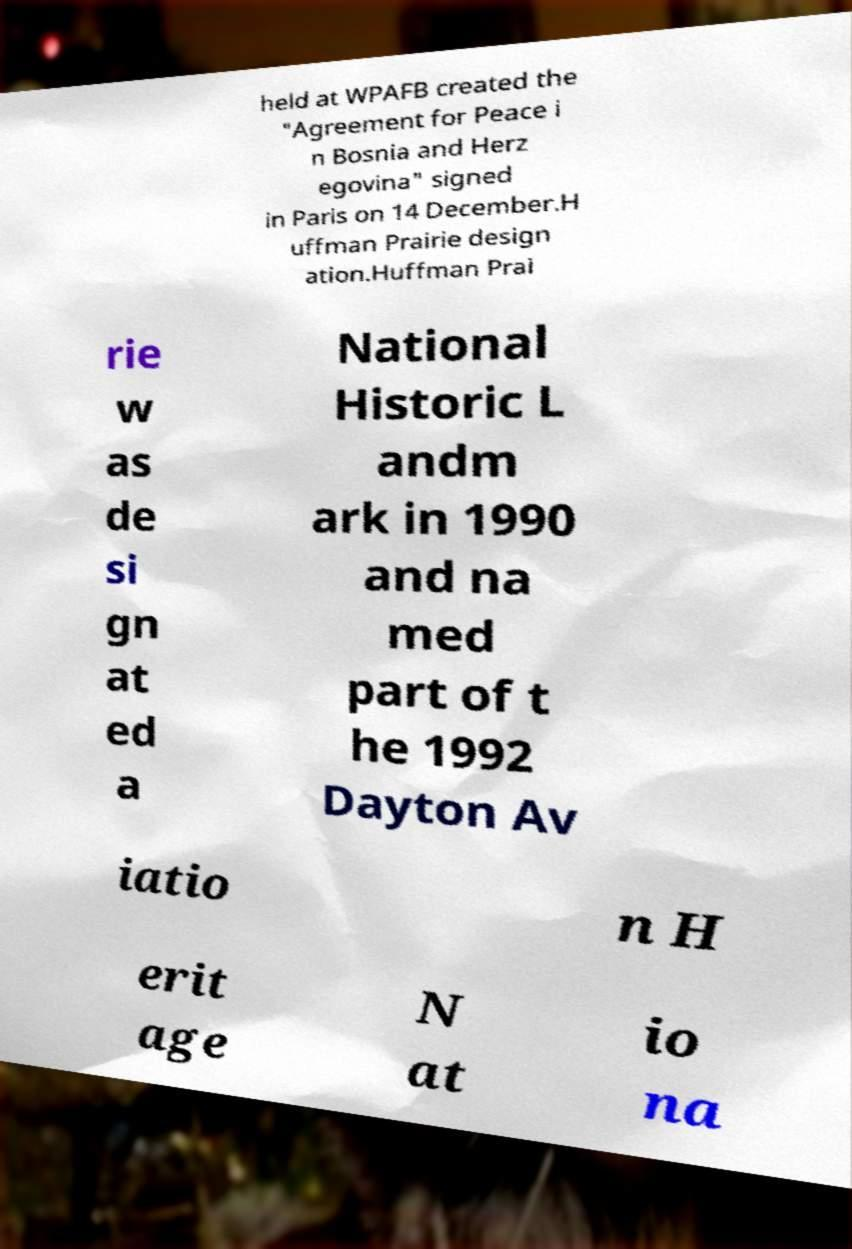For documentation purposes, I need the text within this image transcribed. Could you provide that? held at WPAFB created the "Agreement for Peace i n Bosnia and Herz egovina" signed in Paris on 14 December.H uffman Prairie design ation.Huffman Prai rie w as de si gn at ed a National Historic L andm ark in 1990 and na med part of t he 1992 Dayton Av iatio n H erit age N at io na 